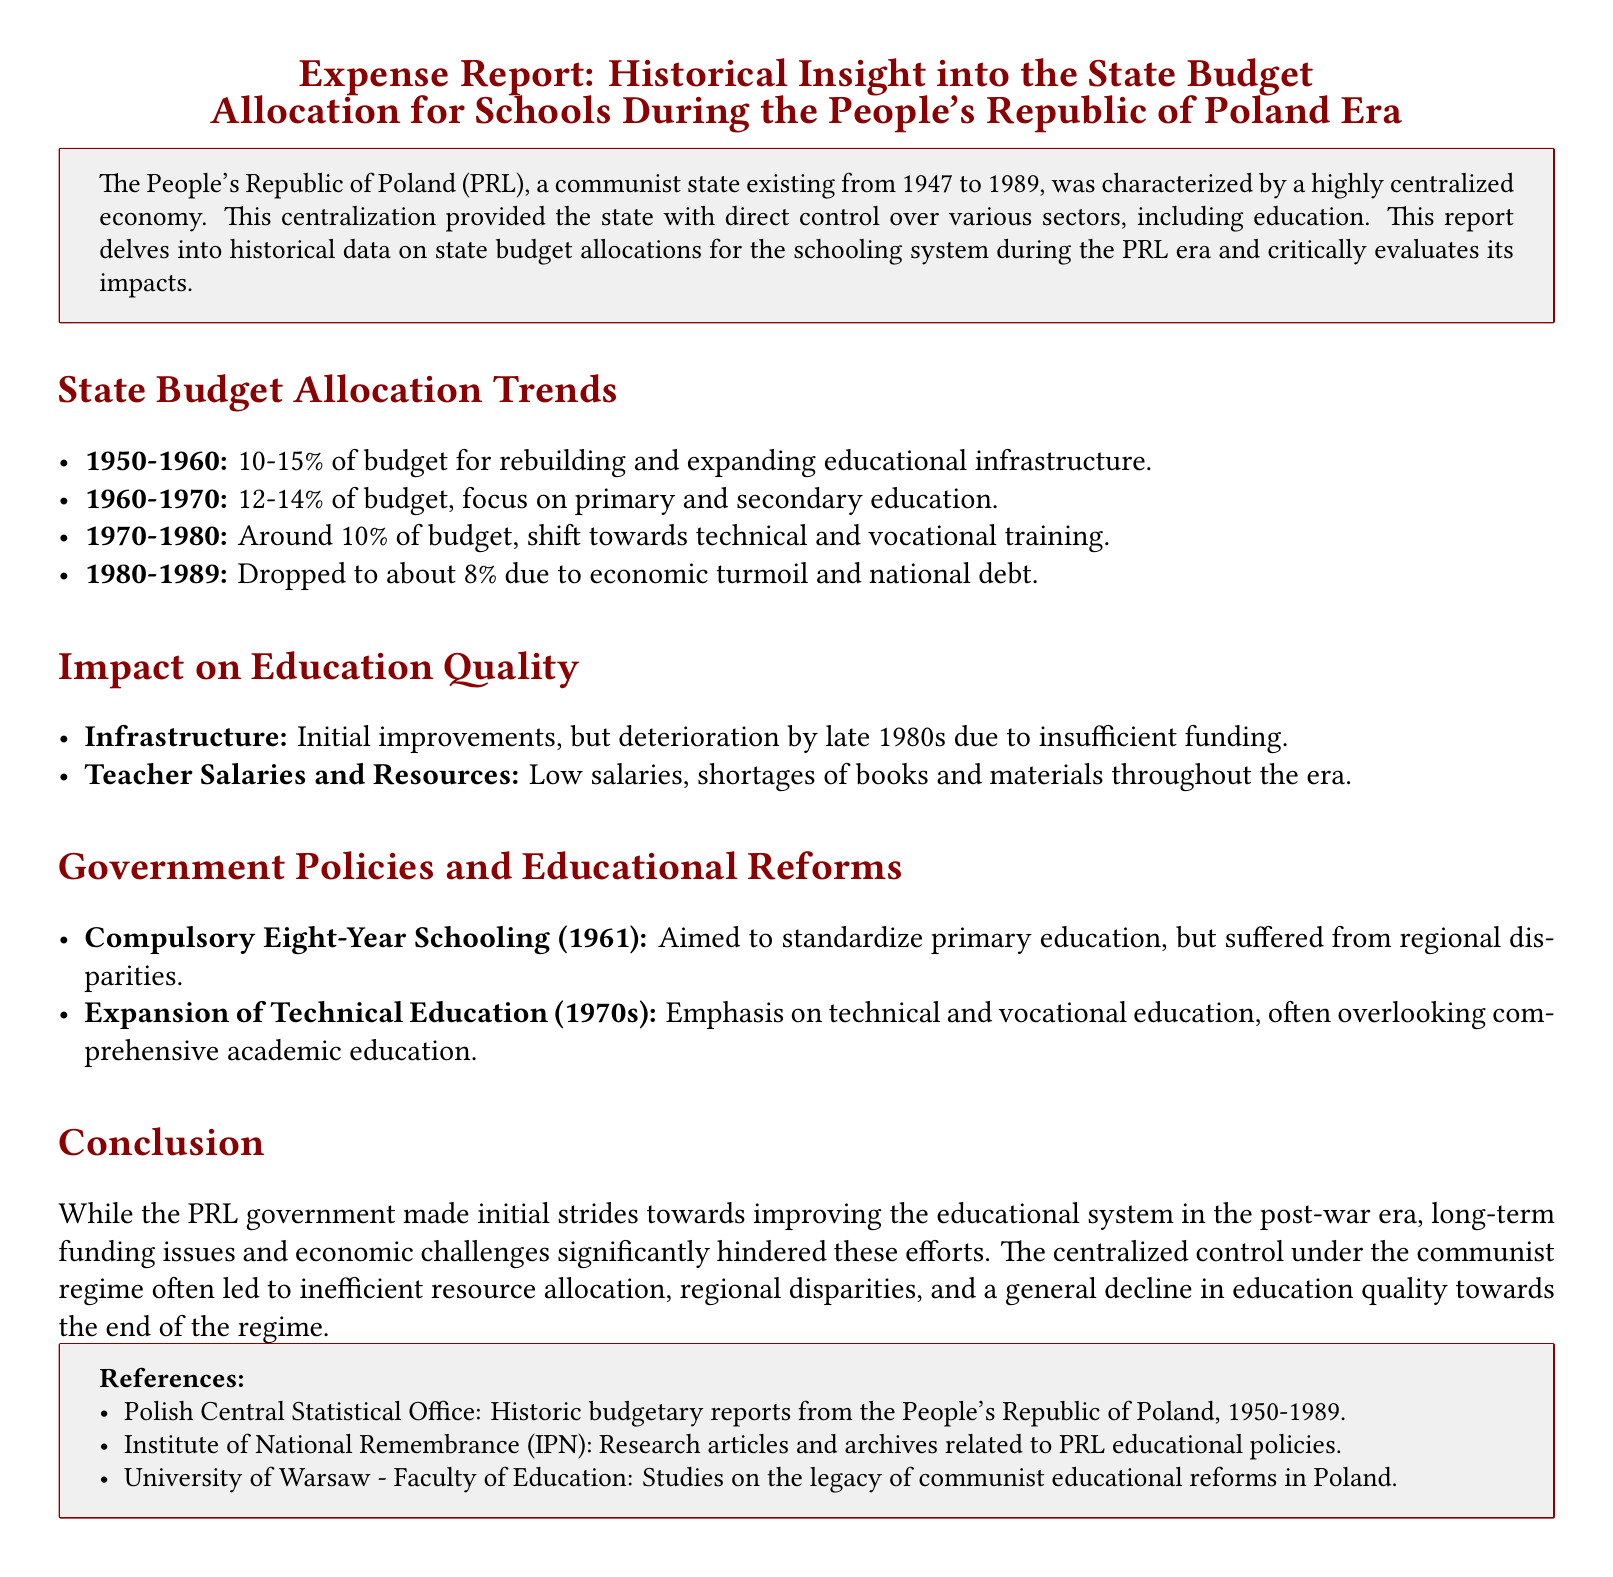What percentage of the state budget was allocated for educational infrastructure from 1950 to 1960? The document states that 10-15% of the budget was allocated for rebuilding and expanding educational infrastructure during this period.
Answer: 10-15% What was the focus of education spending during the 1960-1970 period? The document highlights that the focus during this period was on primary and secondary education.
Answer: Primary and secondary education What was the allocation percentage for education in the 1980-1989 period? According to the report, education spending dropped to about 8% during this period due to economic turmoil and national debt.
Answer: About 8% What significant policy was introduced in 1961? The document mentions the introduction of compulsory eight-year schooling aimed at standardizing primary education.
Answer: Compulsory Eight-Year Schooling What was a major consequence of low teacher salaries during the PRL era? The report notes that low salaries resulted in shortages of books and materials throughout the era.
Answer: Shortages of books and materials Which decade saw an emphasis on technical and vocational education? The document identifies the 1970s as a period that emphasized technical and vocational education.
Answer: 1970s What was a significant characteristic of the educational infrastructure by the late 1980s? The report states that there was a deterioration of infrastructure due to insufficient funding by the late 1980s.
Answer: Deterioration of infrastructure How did centralized control affect resource allocation for education? The document indicates that centralized control often led to inefficient resource allocation and regional disparities.
Answer: Inefficient resource allocation What type of document is this expense report categorized as? The document itself is categorized as an Expense Report focusing on historical insights into state budget allocations.
Answer: Expense Report 